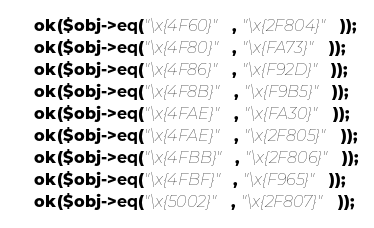<code> <loc_0><loc_0><loc_500><loc_500><_Perl_>    ok($obj->eq("\x{4F60}", "\x{2F804}"));
    ok($obj->eq("\x{4F80}", "\x{FA73}"));
    ok($obj->eq("\x{4F86}", "\x{F92D}"));
    ok($obj->eq("\x{4F8B}", "\x{F9B5}"));
    ok($obj->eq("\x{4FAE}", "\x{FA30}"));
    ok($obj->eq("\x{4FAE}", "\x{2F805}"));
    ok($obj->eq("\x{4FBB}", "\x{2F806}"));
    ok($obj->eq("\x{4FBF}", "\x{F965}"));
    ok($obj->eq("\x{5002}", "\x{2F807}"));</code> 